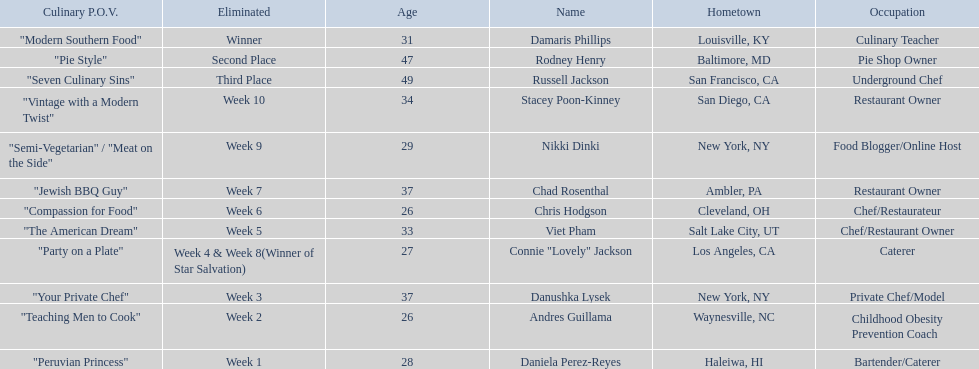Excluding the winner, and second and third place winners, who were the contestants eliminated? Stacey Poon-Kinney, Nikki Dinki, Chad Rosenthal, Chris Hodgson, Viet Pham, Connie "Lovely" Jackson, Danushka Lysek, Andres Guillama, Daniela Perez-Reyes. Of these contestants, who were the last five eliminated before the winner, second, and third place winners were announce? Stacey Poon-Kinney, Nikki Dinki, Chad Rosenthal, Chris Hodgson, Viet Pham. Of these five contestants, was nikki dinki or viet pham eliminated first? Viet Pham. 